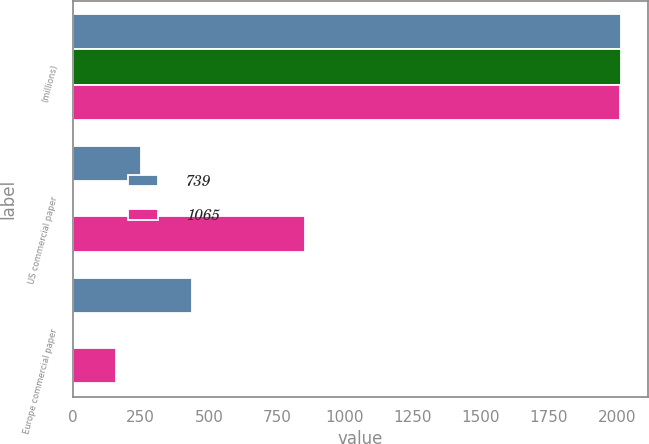<chart> <loc_0><loc_0><loc_500><loc_500><stacked_bar_chart><ecel><fcel>(millions)<fcel>US commercial paper<fcel>Europe commercial paper<nl><fcel>739<fcel>2013<fcel>249<fcel>437<nl><fcel>nan<fcel>2013<fcel>0.22<fcel>0.23<nl><fcel>1065<fcel>2012<fcel>853<fcel>159<nl></chart> 